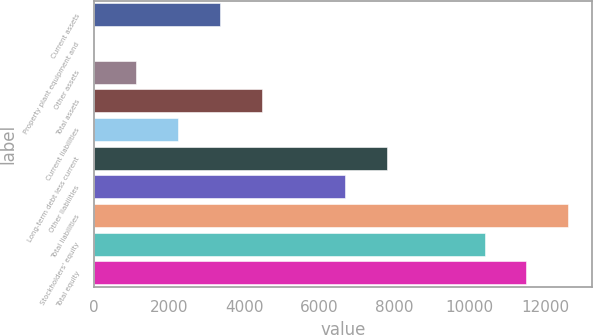Convert chart. <chart><loc_0><loc_0><loc_500><loc_500><bar_chart><fcel>Current assets<fcel>Property plant equipment and<fcel>Other assets<fcel>Total assets<fcel>Current liabilities<fcel>Long-term debt less current<fcel>Other liabilities<fcel>Total liabilities<fcel>Stockholders' equity<fcel>Total equity<nl><fcel>3345.5<fcel>11<fcel>1122.5<fcel>4457<fcel>2234<fcel>7791.5<fcel>6680<fcel>12619<fcel>10396<fcel>11507.5<nl></chart> 